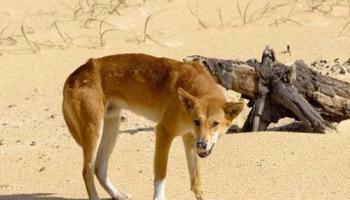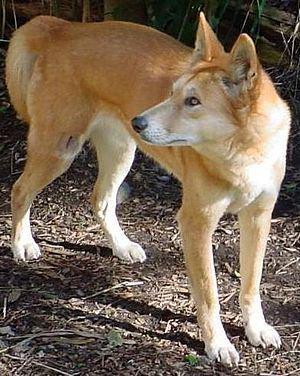The first image is the image on the left, the second image is the image on the right. Given the left and right images, does the statement "There are more dogs in the right image than in the left." hold true? Answer yes or no. No. The first image is the image on the left, the second image is the image on the right. Analyze the images presented: Is the assertion "One animal is standing in the image on the left." valid? Answer yes or no. Yes. 